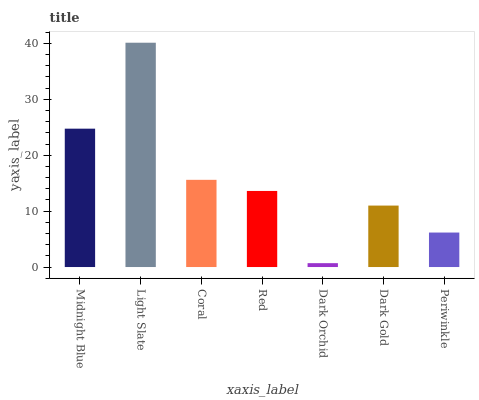Is Coral the minimum?
Answer yes or no. No. Is Coral the maximum?
Answer yes or no. No. Is Light Slate greater than Coral?
Answer yes or no. Yes. Is Coral less than Light Slate?
Answer yes or no. Yes. Is Coral greater than Light Slate?
Answer yes or no. No. Is Light Slate less than Coral?
Answer yes or no. No. Is Red the high median?
Answer yes or no. Yes. Is Red the low median?
Answer yes or no. Yes. Is Midnight Blue the high median?
Answer yes or no. No. Is Midnight Blue the low median?
Answer yes or no. No. 